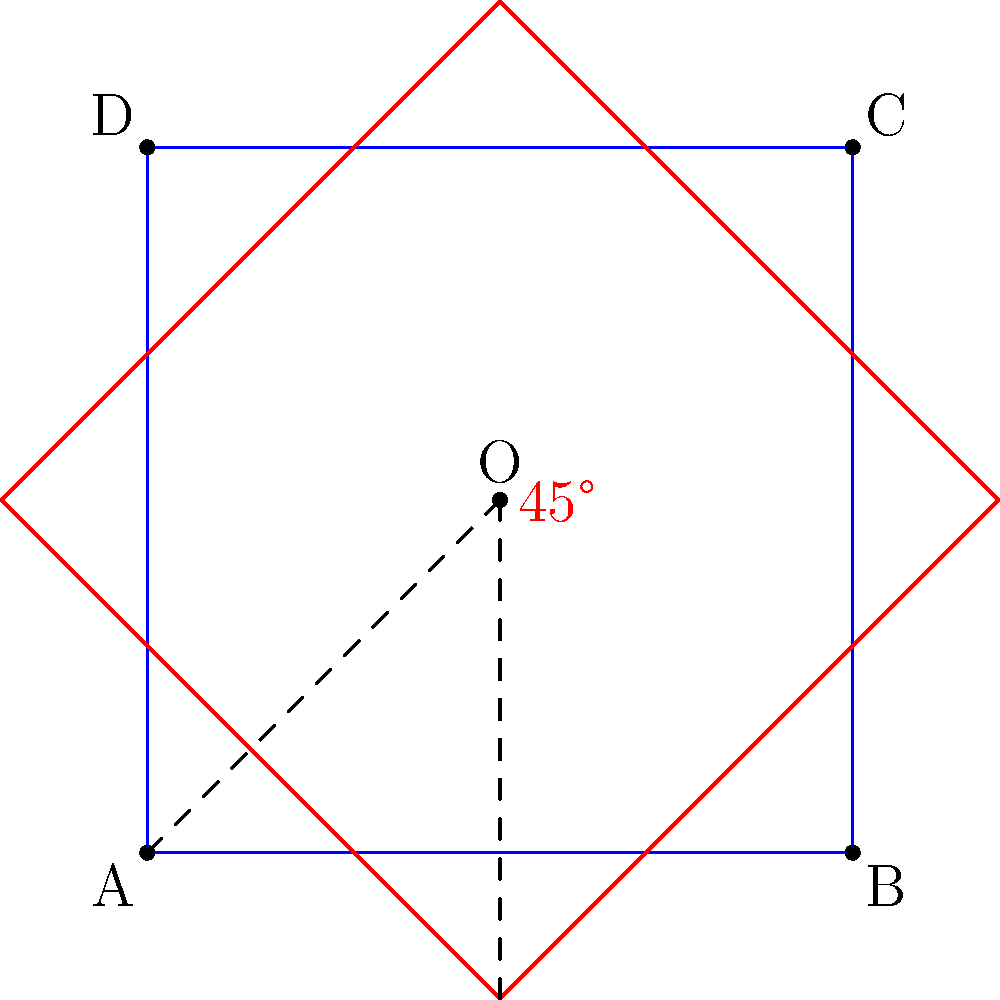A square ABCD represents a client's comfort zone, and point O represents their core self. If the square is rotated 45° clockwise around point O to symbolize adapting to a new environment, what is the coordinates of point A after rotation, given that the original coordinates of A are (0,0) and O is at (1,1)? To solve this problem, we'll use the rotation formula and follow these steps:

1) The rotation formula for a point (x,y) rotated θ degrees counterclockwise around the origin is:
   $$(x', y') = (x \cos θ - y \sin θ, x \sin θ + y \cos θ)$$

2) However, we're rotating around (1,1), not the origin, and clockwise instead of counterclockwise. So we need to:
   a) Translate the point so that O becomes the origin
   b) Rotate using -45° (negative because it's clockwise)
   c) Translate back

3) Translating A(0,0) so that O(1,1) becomes the origin:
   $$(0-1, 0-1) = (-1, -1)$$

4) Now we rotate (-1, -1) by -45°:
   $$\cos(-45°) = \frac{\sqrt{2}}{2}, \sin(-45°) = -\frac{\sqrt{2}}{2}$$
   $$x' = -1 \cdot \frac{\sqrt{2}}{2} - (-1) \cdot (-\frac{\sqrt{2}}{2}) = -\sqrt{2}$$
   $$y' = -1 \cdot (-\frac{\sqrt{2}}{2}) + (-1) \cdot \frac{\sqrt{2}}{2} = 0$$

5) Finally, we translate back by adding (1,1):
   $$(-\sqrt{2} + 1, 0 + 1) = (1-\sqrt{2}, 1)$$

Therefore, the new coordinates of A after rotation are $(1-\sqrt{2}, 1)$.
Answer: $(1-\sqrt{2}, 1)$ 